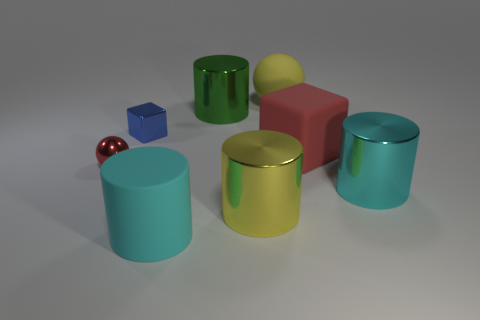How many objects are either big yellow objects behind the tiny blue shiny thing or cyan shiny cylinders?
Provide a short and direct response. 2. There is a big matte thing that is on the right side of the yellow object behind the cyan shiny cylinder; what is its shape?
Your response must be concise. Cube. Is there a red sphere of the same size as the red metallic object?
Keep it short and to the point. No. Is the number of tiny blue metal cubes greater than the number of small metallic objects?
Give a very brief answer. No. Is the size of the yellow thing in front of the small blue metal block the same as the shiny object to the right of the yellow rubber thing?
Your response must be concise. Yes. What number of large things are left of the large matte sphere and behind the tiny red metallic object?
Ensure brevity in your answer.  1. There is a small thing that is the same shape as the large yellow matte thing; what is its color?
Keep it short and to the point. Red. Is the number of large gray cubes less than the number of red spheres?
Provide a succinct answer. Yes. There is a metal sphere; does it have the same size as the yellow object that is in front of the tiny ball?
Provide a succinct answer. No. What is the color of the big metal cylinder behind the tiny metallic thing that is in front of the blue object?
Provide a short and direct response. Green. 